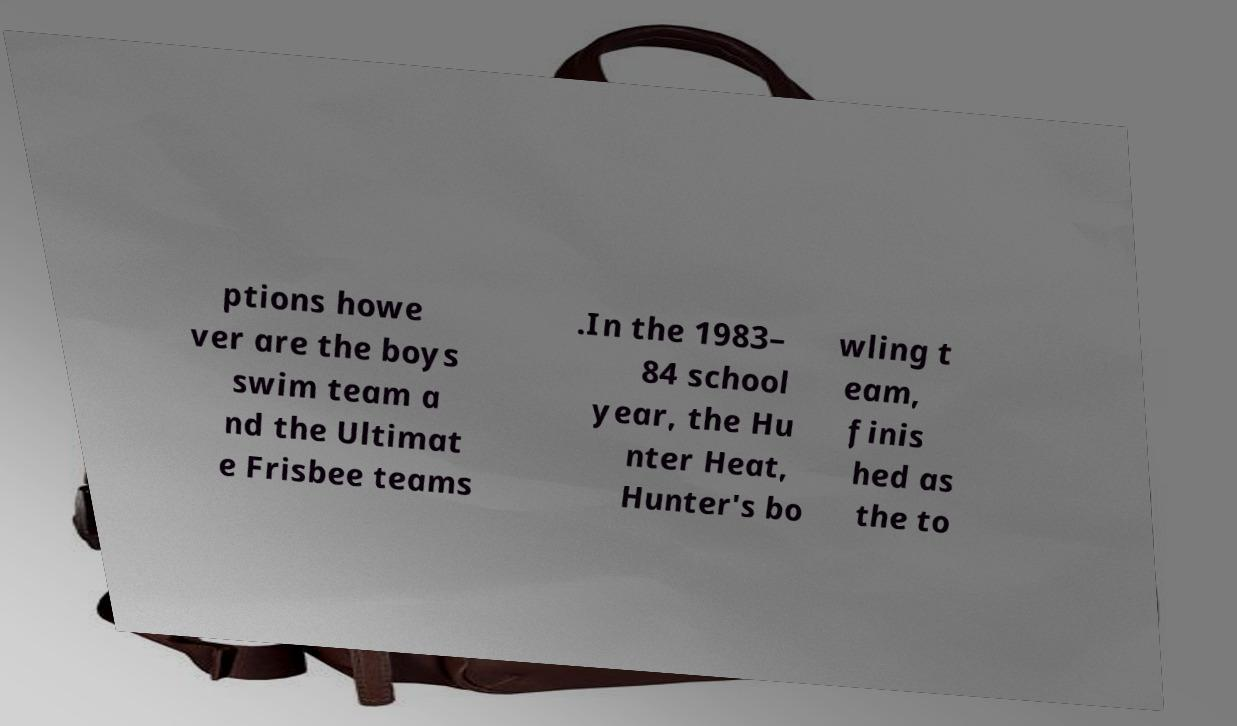What messages or text are displayed in this image? I need them in a readable, typed format. ptions howe ver are the boys swim team a nd the Ultimat e Frisbee teams .In the 1983– 84 school year, the Hu nter Heat, Hunter's bo wling t eam, finis hed as the to 